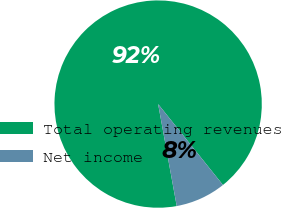Convert chart. <chart><loc_0><loc_0><loc_500><loc_500><pie_chart><fcel>Total operating revenues<fcel>Net income<nl><fcel>92.12%<fcel>7.88%<nl></chart> 